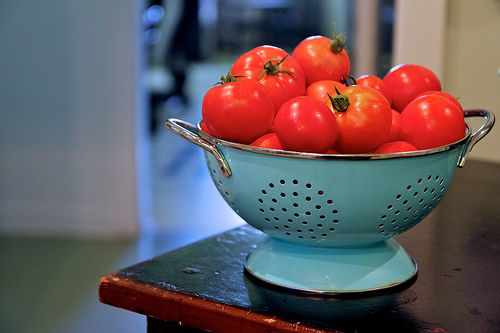<image>
Is there a tomato on the metal? Yes. Looking at the image, I can see the tomato is positioned on top of the metal, with the metal providing support. Is the tomato on the floor? No. The tomato is not positioned on the floor. They may be near each other, but the tomato is not supported by or resting on top of the floor. 